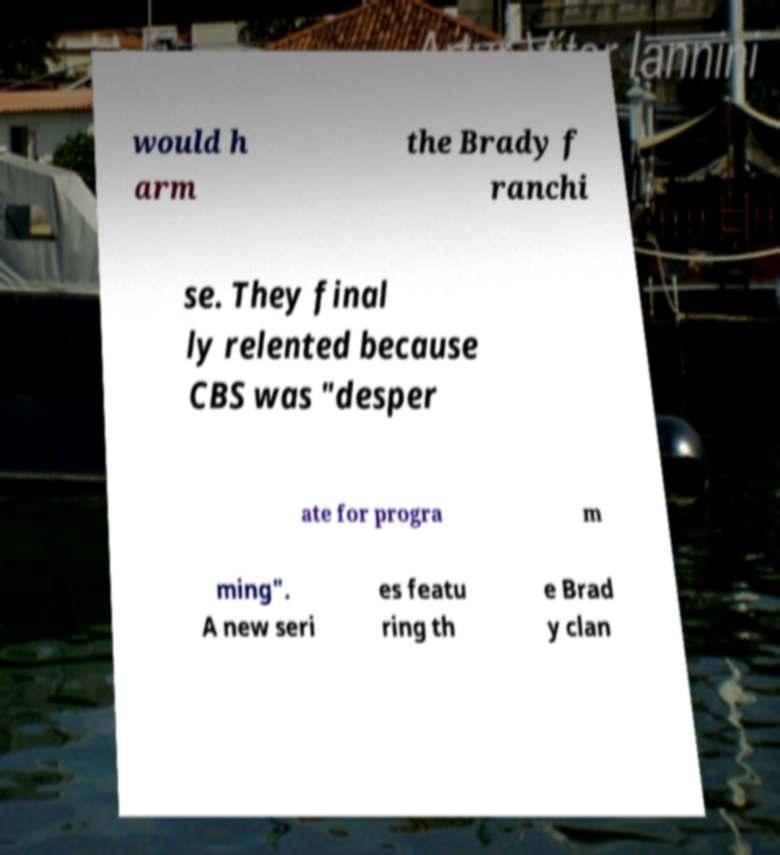I need the written content from this picture converted into text. Can you do that? would h arm the Brady f ranchi se. They final ly relented because CBS was "desper ate for progra m ming". A new seri es featu ring th e Brad y clan 